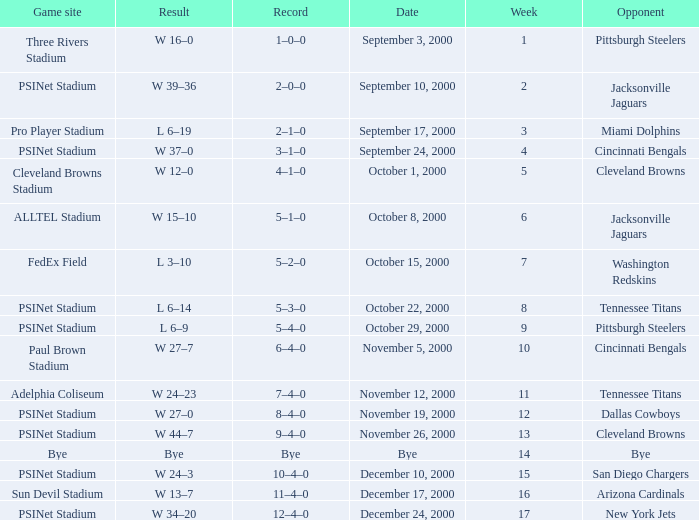What game site has a result of bye? Bye. 